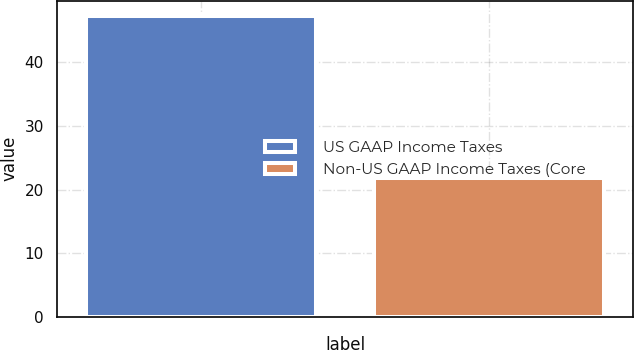<chart> <loc_0><loc_0><loc_500><loc_500><bar_chart><fcel>US GAAP Income Taxes<fcel>Non-US GAAP Income Taxes (Core<nl><fcel>47.3<fcel>21.8<nl></chart> 